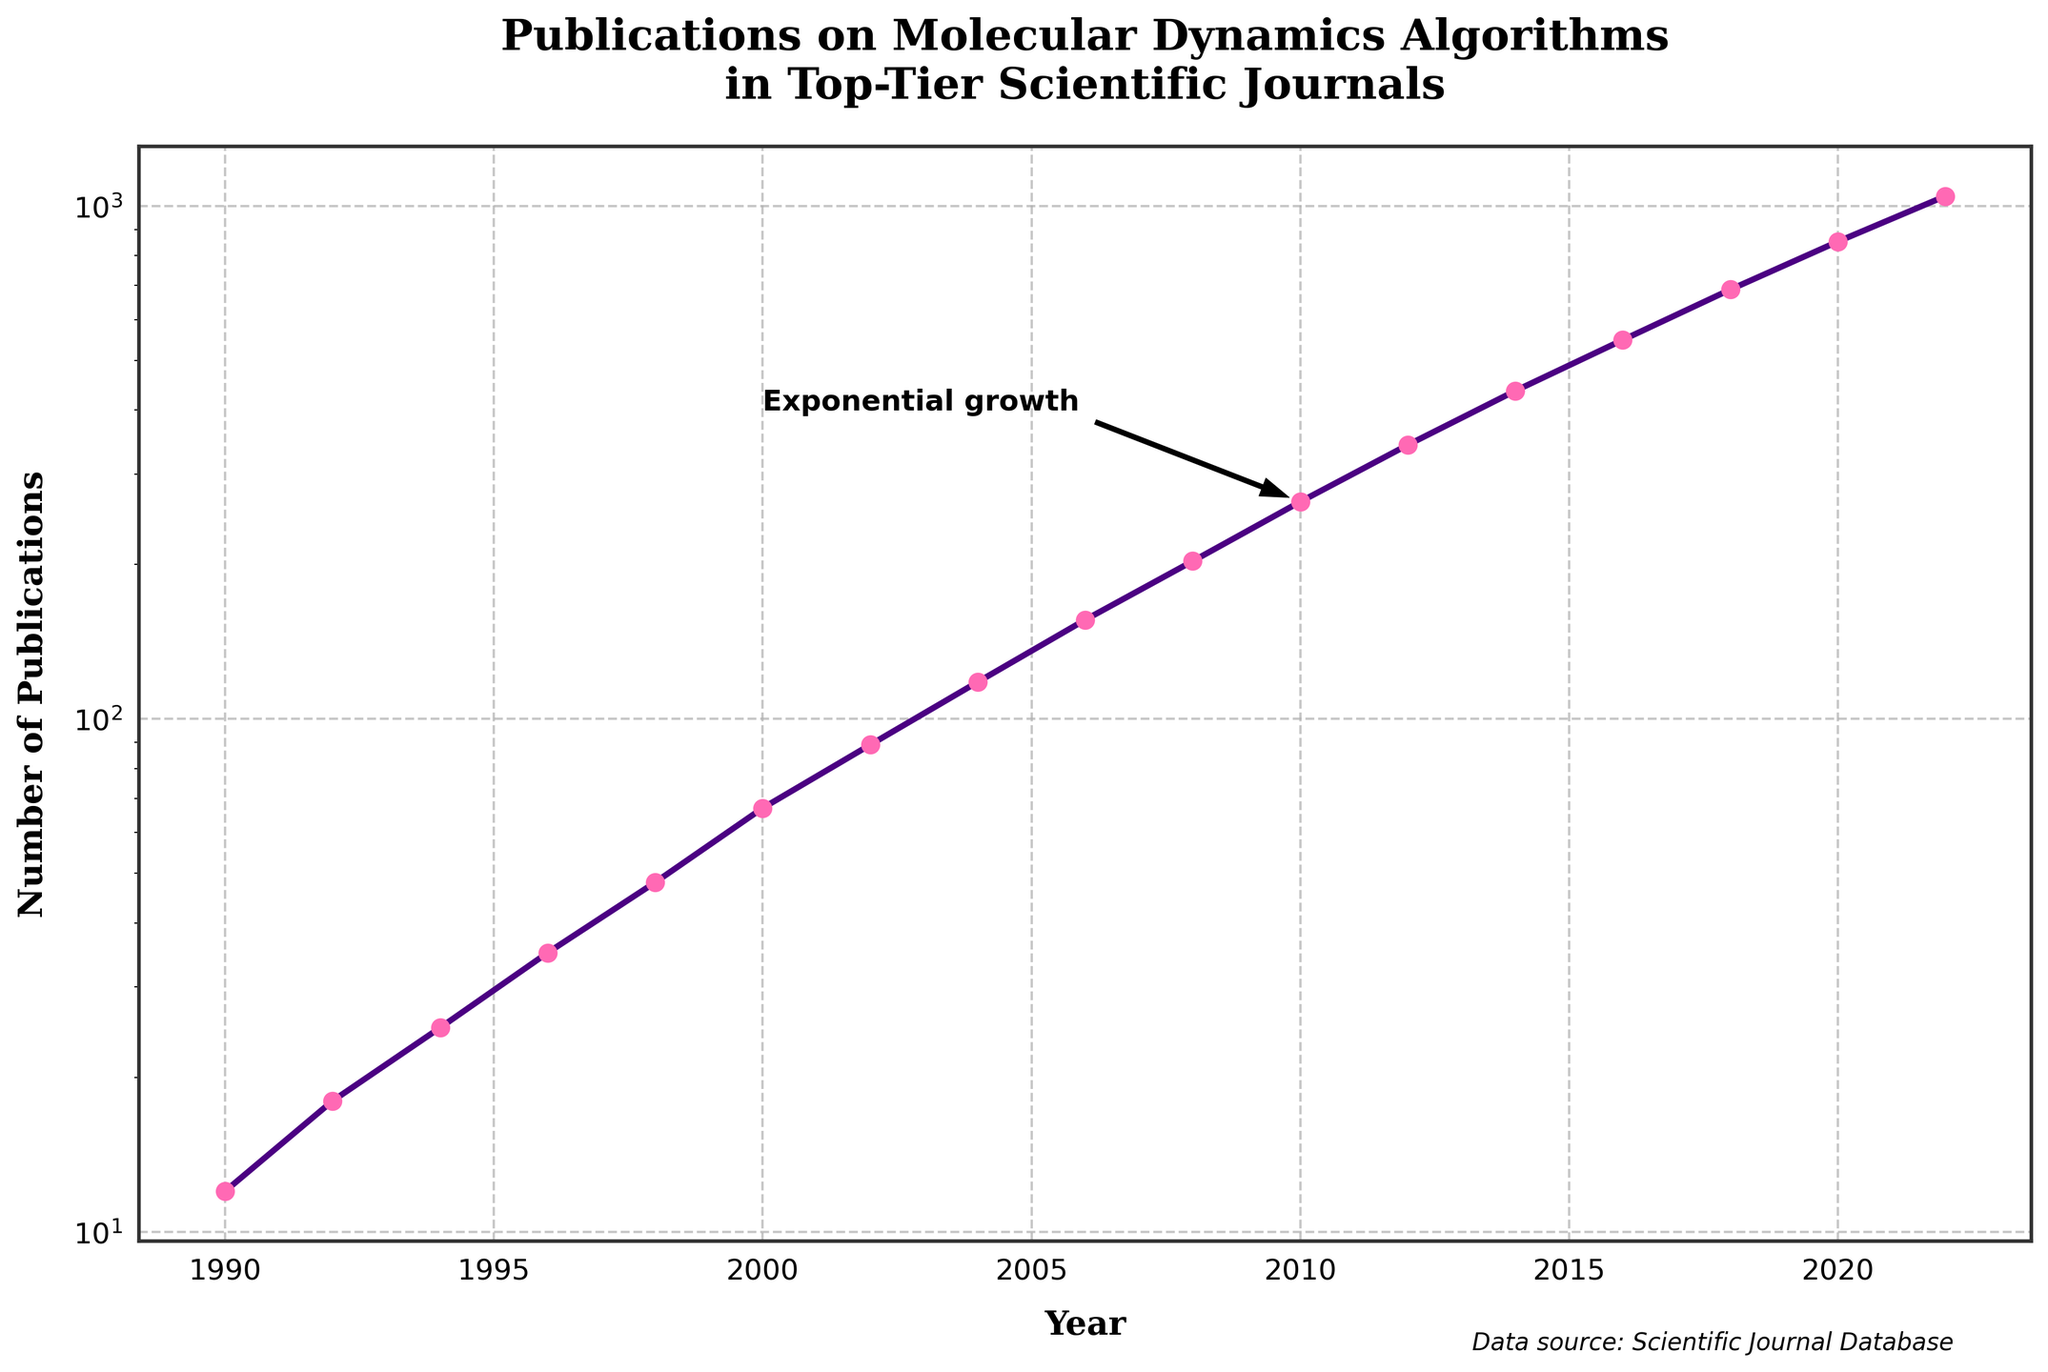what's the largest number of publications recorded in a single year? The largest number of publications can be found by looking at the peak value on the y-axis. The highest point is at 2022, which records 1045 publications.
Answer: 1045 During which period did the number of publications increase the most rapidly? To determine the period of most rapid increase, we should look for the steepest slope in the line plot. From 2016 to 2022, the line segment is almost vertical, indicating the most rapid increase in publications.
Answer: 2016 to 2022 What is the trend of the number of publications between 1990 and 2000? Examine the line segment from 1990 to 2000; there is a consistent upward trend, starting from 12 publications in 1990 to 67 publications in 2000.
Answer: Increasing How many more publications were recorded in 2020 compared to 2000? To find this, subtract the number of publications in 2000 from that in 2020. Specifically, 852 (2020) - 67 (2000) = 785 extra publications in 2020.
Answer: 785 Which year saw a significant annotation in the plot, and why? Look for the year highlighted by an annotation and arrow. The year 2010 is marked with an annotation indicating "Exponential growth," pointing to a significant increase in publications.
Answer: 2010 What is the overall trend of publications over the entire period from 1990 to 2022? Observing the entire line plot from 1990 to 2022, it steadily inclines upward with accelerating growth, indicating an overall increasing trend in publications.
Answer: Increasing What is the logarithmic trend suggested by the y-axis, and why is this scale used? The y-axis is on a logarithmic scale, suggesting an exponential growth trend in the number of publications. This scale helps better visualize rapidly increasing data.
Answer: Exponential growth Between which consecutive years did publications first exceed 100? By checking the data points, publications exceeded 100 between 2002 (89) and 2004 (118).
Answer: 2002 and 2004 What visual elements highlight the title and axes of the plot? The title and axes labels are bold and large in font, enhancing their visibility. The axes labels also have padding to distinguish them from the data points.
Answer: Bold and large text How has the number of publications changed every decade starting from 1990? Analyze the number of publications at each ten-year interval: 1990 (12), 2000 (67), 2010 (265), 2020 (852). This shows significant increases in each decade (55, 198, 587 respectively).
Answer: Increased significantly every decade 